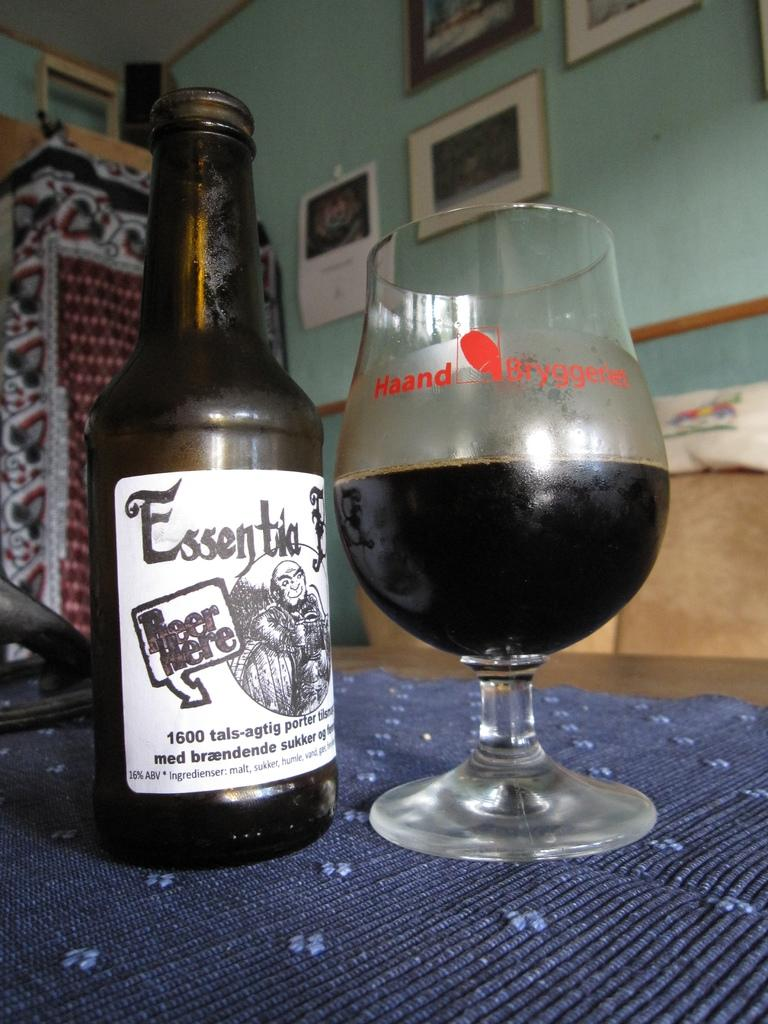What is on the table in the image? There is a bottle and a glass on the table in the image. What color is the wall in the background? There is a blue wall in the background. What can be seen hanging on the blue wall? There are photo frames hanging on the blue wall. What time is displayed on the watch in the image? There is no watch present in the image. How does the sun affect the objects in the image? The image does not show the sun or its effects on the objects. 